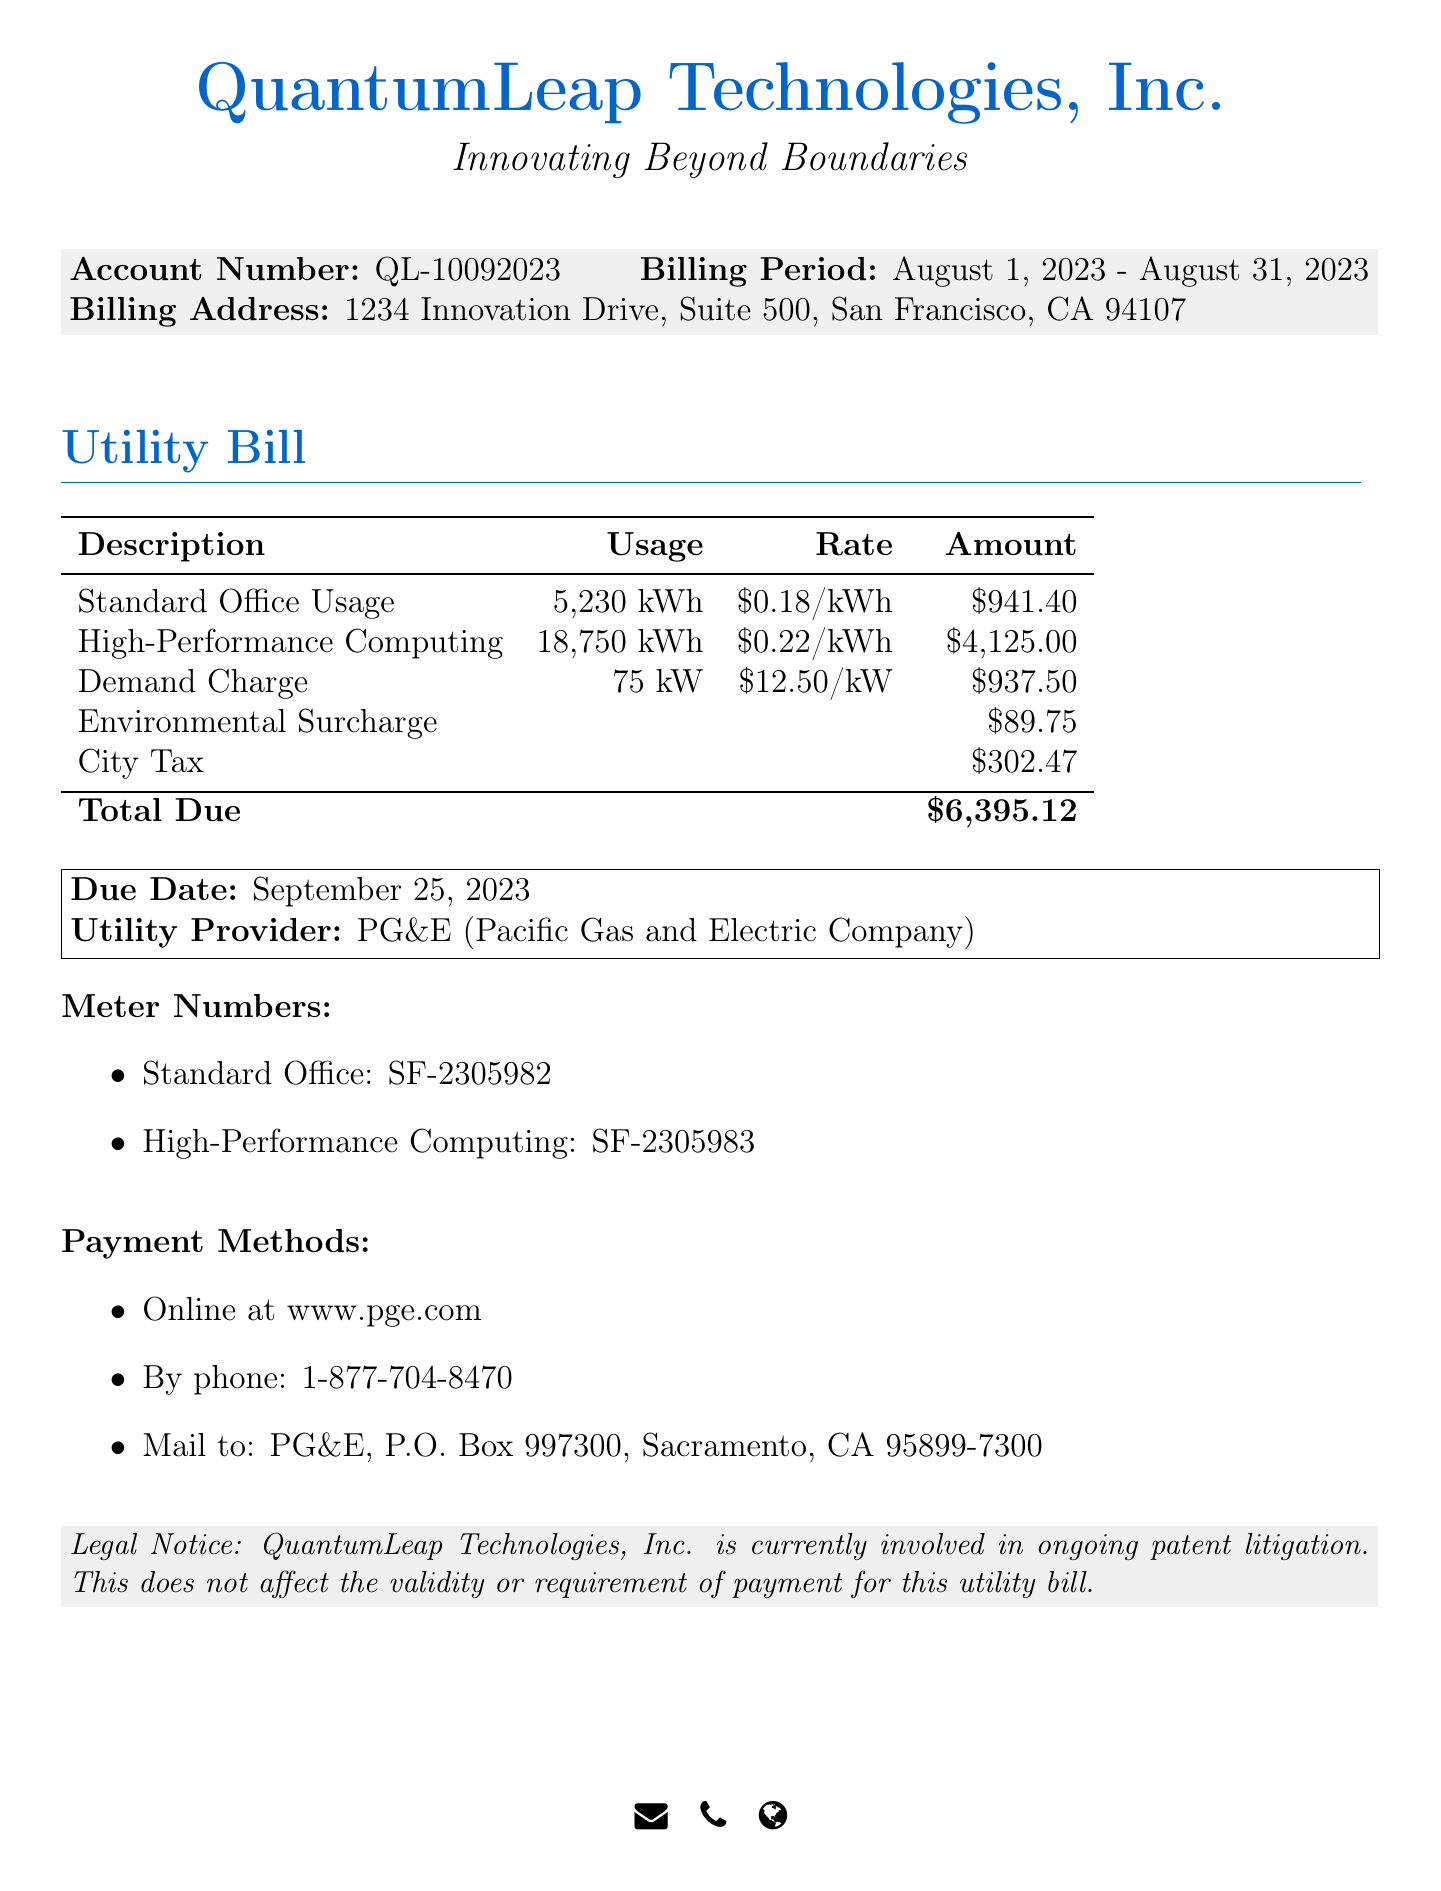What is the account number? The account number is provided in the billing information section of the document.
Answer: QL-10092023 What is the billing period? The billing period indicates the time frame for which charges are applied, shown at the beginning of the document.
Answer: August 1, 2023 - August 31, 2023 What is the total due amount? The total due is the final amount calculated at the end of the billing section.
Answer: $6,395.12 What is the usage for High-Performance Computing? The usage for High-Performance Computing is given in the tabular section detailing the charges.
Answer: 18,750 kWh What is the rate for standard office usage? The rate appears next to the description for standard office usage in the billing table.
Answer: $0.18/kWh What is the due date for the payment? The due date is mentioned in the highlighted box area towards the end of the document.
Answer: September 25, 2023 What is the utility provider's name? The utility provider is listed near the payment methods section of the document.
Answer: PG&E (Pacific Gas and Electric Company) How many meters are listed in the document? The document includes a section that details the meter numbers pertaining to different usages.
Answer: 2 What charge has the highest amount? By reviewing the billing table, the charge amounts are compared to identify the highest.
Answer: High-Performance Computing 